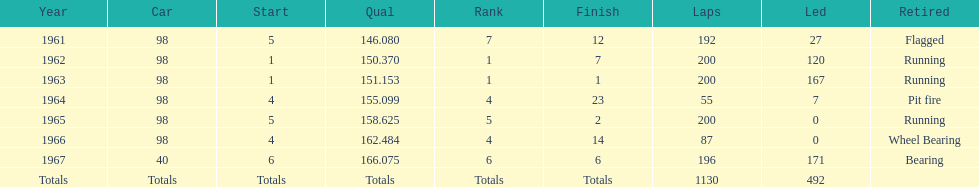How often should the races be finished by running? 3. 